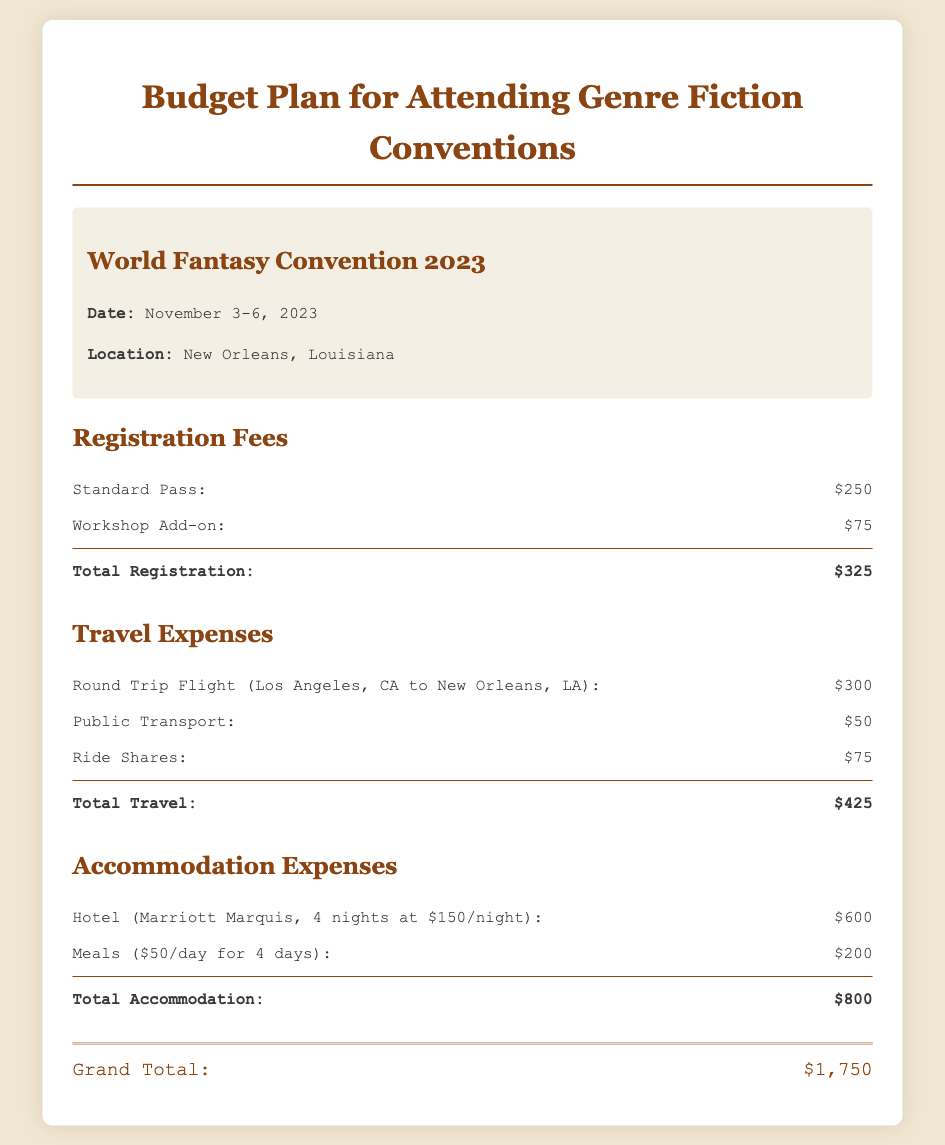what is the total registration fee? The total registration fee is the sum of the Standard Pass and Workshop Add-on, which is $250 + $75 = $325.
Answer: $325 what are the dates of the World Fantasy Convention? The dates of the convention are specified in the document as November 3-6, 2023.
Answer: November 3-6, 2023 how much is the hotel accommodation per night? The document states that the hotel costs $150 per night for the duration of the stay.
Answer: $150 what is included in the travel expenses? Travel expenses include Round Trip Flight, Public Transport, and Ride Shares, as detailed in the document.
Answer: Round Trip Flight, Public Transport, Ride Shares what is the grand total for the budget plan? The grand total is calculated from the sums of registration, travel, and accommodation expenses, totaling $1,750.
Answer: $1,750 how many nights will the hotel stay be? The document specifies that the hotel stay is for 4 nights during the convention.
Answer: 4 nights what is the cost of meals for the duration of the event? Meals are calculated at $50 per day for 4 days, totaling $200.
Answer: $200 how much does a workshop add-on cost? The document lists the cost of the workshop add-on as $75.
Answer: $75 